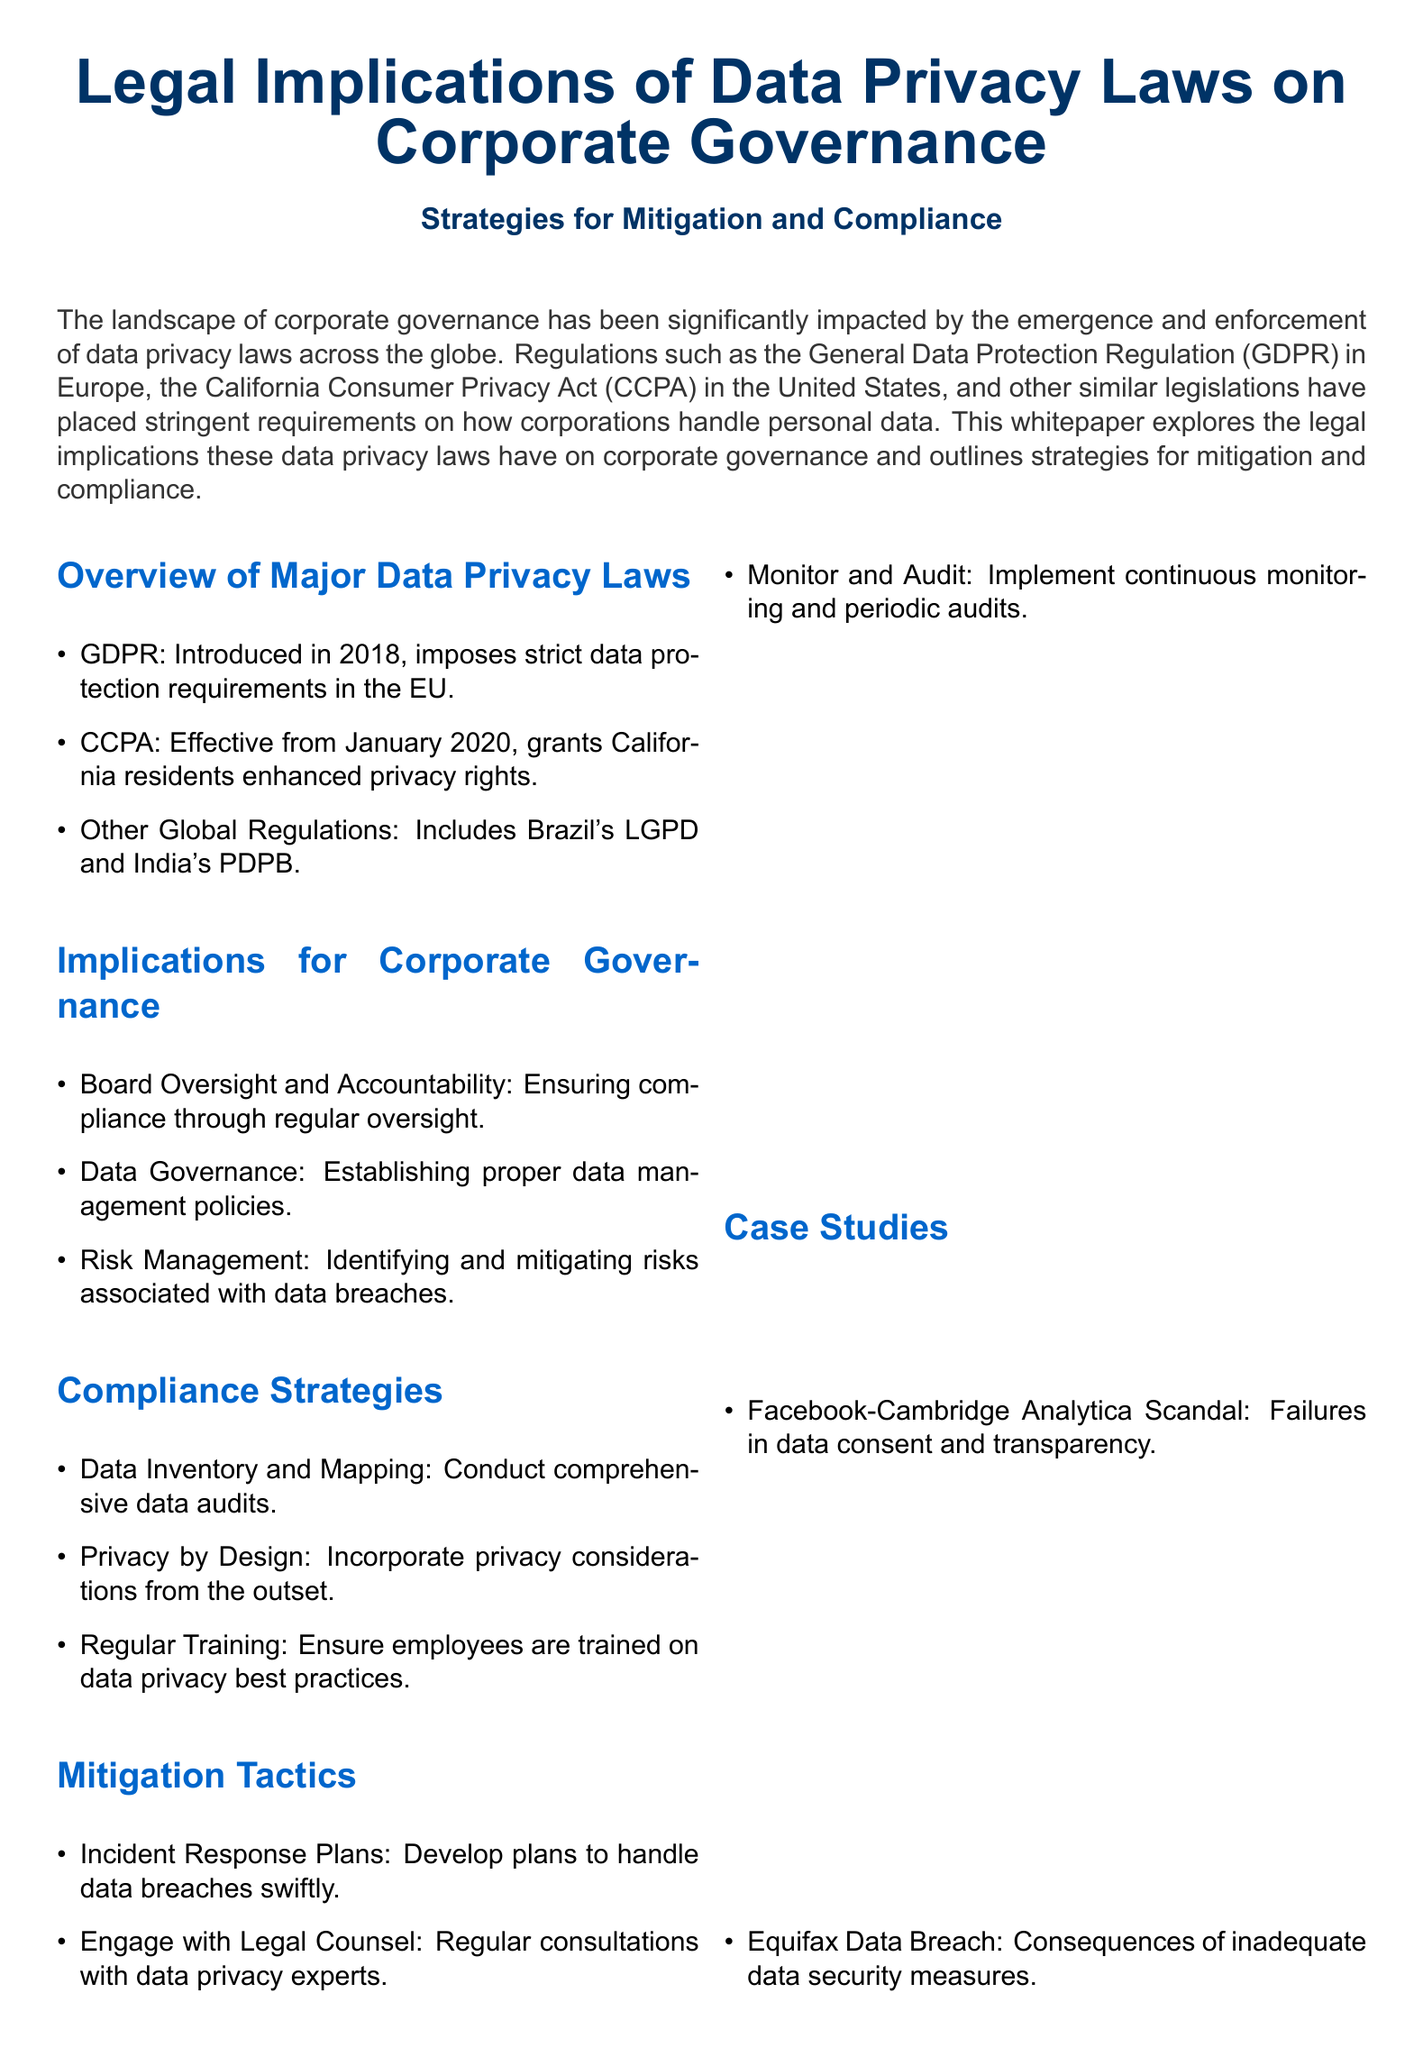What is GDPR? GDPR stands for the General Data Protection Regulation, which is a data protection regulation in the EU introduced in 2018.
Answer: General Data Protection Regulation When did CCPA become effective? CCPA, the California Consumer Privacy Act, became effective from January 2020.
Answer: January 2020 Name a significant consequence of the Equifax Data Breach. The document states that the Equifax Data Breach highlighted consequences of inadequate data security measures.
Answer: Inadequate data security measures What is a recommended compliance strategy? One recommended compliance strategy mentioned in the document is conducting comprehensive data audits.
Answer: Data Inventory and Mapping What does 'Privacy by Design' advocate? 'Privacy by Design' advocates incorporating privacy considerations from the outset of projects or systems handling personal data.
Answer: Incorporate privacy considerations from the outset How many global regulations are mentioned in the document? The document specifically mentions three: GDPR, CCPA, and other global regulations such as Brazil's LGPD and India's PDPB.
Answer: Three What is the purpose of incident response plans? Incident response plans are developed to handle data breaches swiftly.
Answer: Handle data breaches swiftly What are organizations advised to monitor? Organizations are advised to implement continuous monitoring and periodic audits concerning their data privacy practices.
Answer: Continuous monitoring and periodic audits How can corporate governance mitigate data privacy risks? By understanding legal implications and implementing effective strategies for compliance and mitigation, corporate governance can mitigate data privacy risks.
Answer: Understanding legal implications and implementing effective strategies 